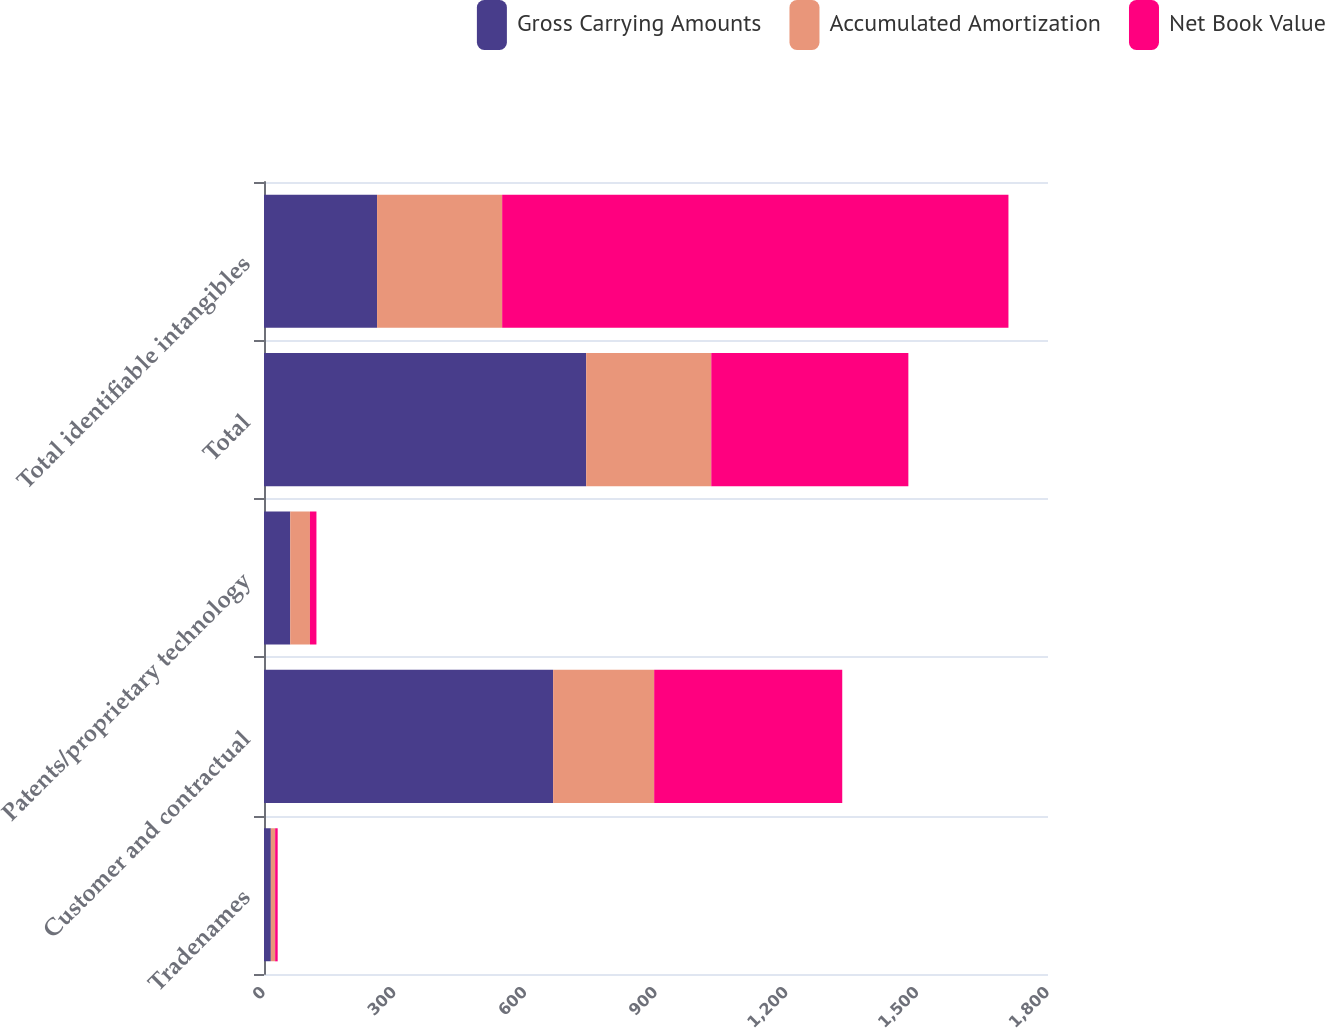<chart> <loc_0><loc_0><loc_500><loc_500><stacked_bar_chart><ecel><fcel>Tradenames<fcel>Customer and contractual<fcel>Patents/proprietary technology<fcel>Total<fcel>Total identifiable intangibles<nl><fcel>Gross Carrying Amounts<fcel>15.7<fcel>663.8<fcel>60.2<fcel>739.7<fcel>259.6<nl><fcel>Accumulated Amortization<fcel>9.9<fcel>232<fcel>45.3<fcel>287.2<fcel>287.2<nl><fcel>Net Book Value<fcel>5.8<fcel>431.8<fcel>14.9<fcel>452.5<fcel>1162.4<nl></chart> 